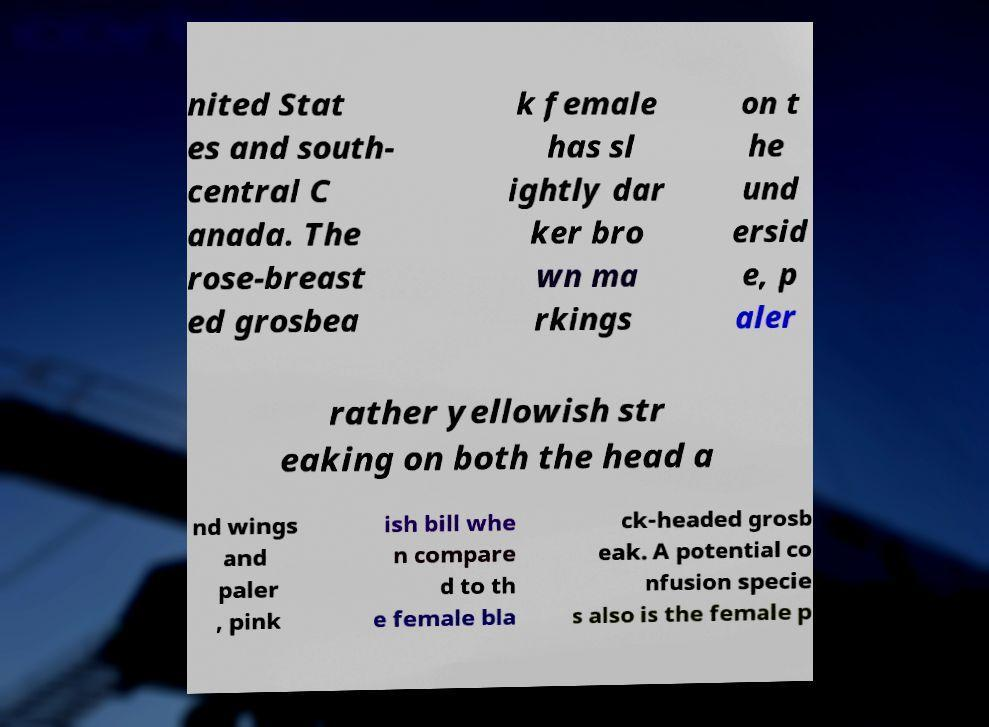Could you extract and type out the text from this image? nited Stat es and south- central C anada. The rose-breast ed grosbea k female has sl ightly dar ker bro wn ma rkings on t he und ersid e, p aler rather yellowish str eaking on both the head a nd wings and paler , pink ish bill whe n compare d to th e female bla ck-headed grosb eak. A potential co nfusion specie s also is the female p 